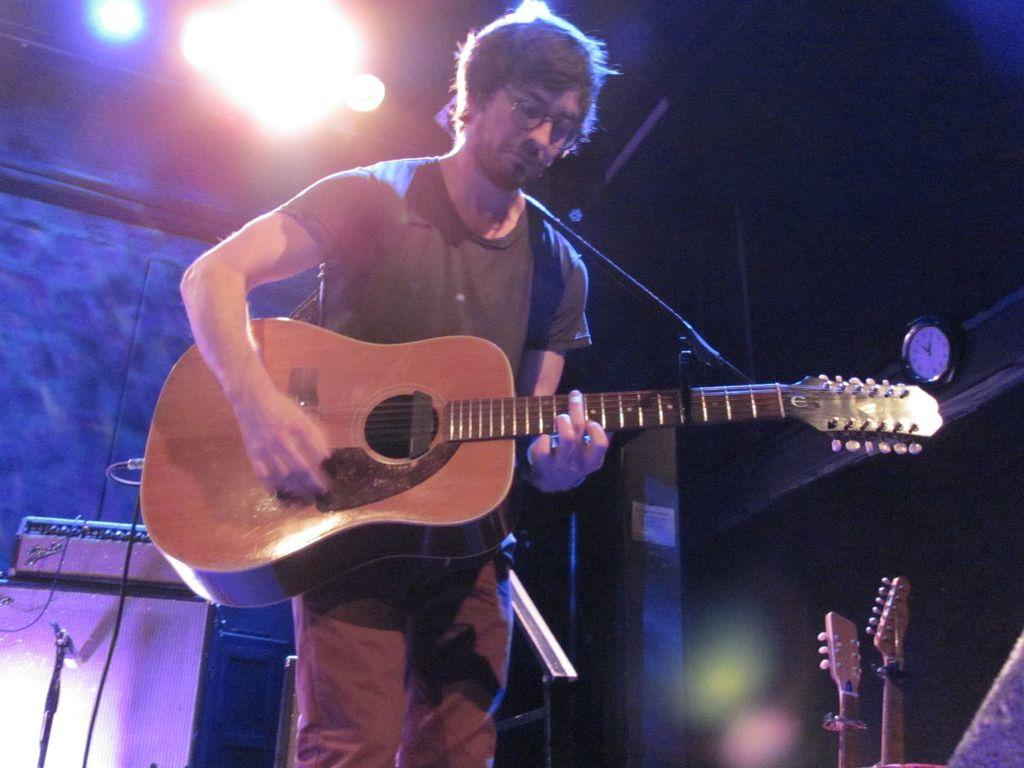Who is the main subject in the image? There is a man in the image. What is the man doing in the image? The man is playing a guitar. What else can be seen in the image besides the man? There are musical instruments and lights in the image. What type of copper material is used to make the guitar in the image? There is no mention of copper or any specific material used to make the guitar in the image. The guitar's material cannot be determined from the provided facts. 